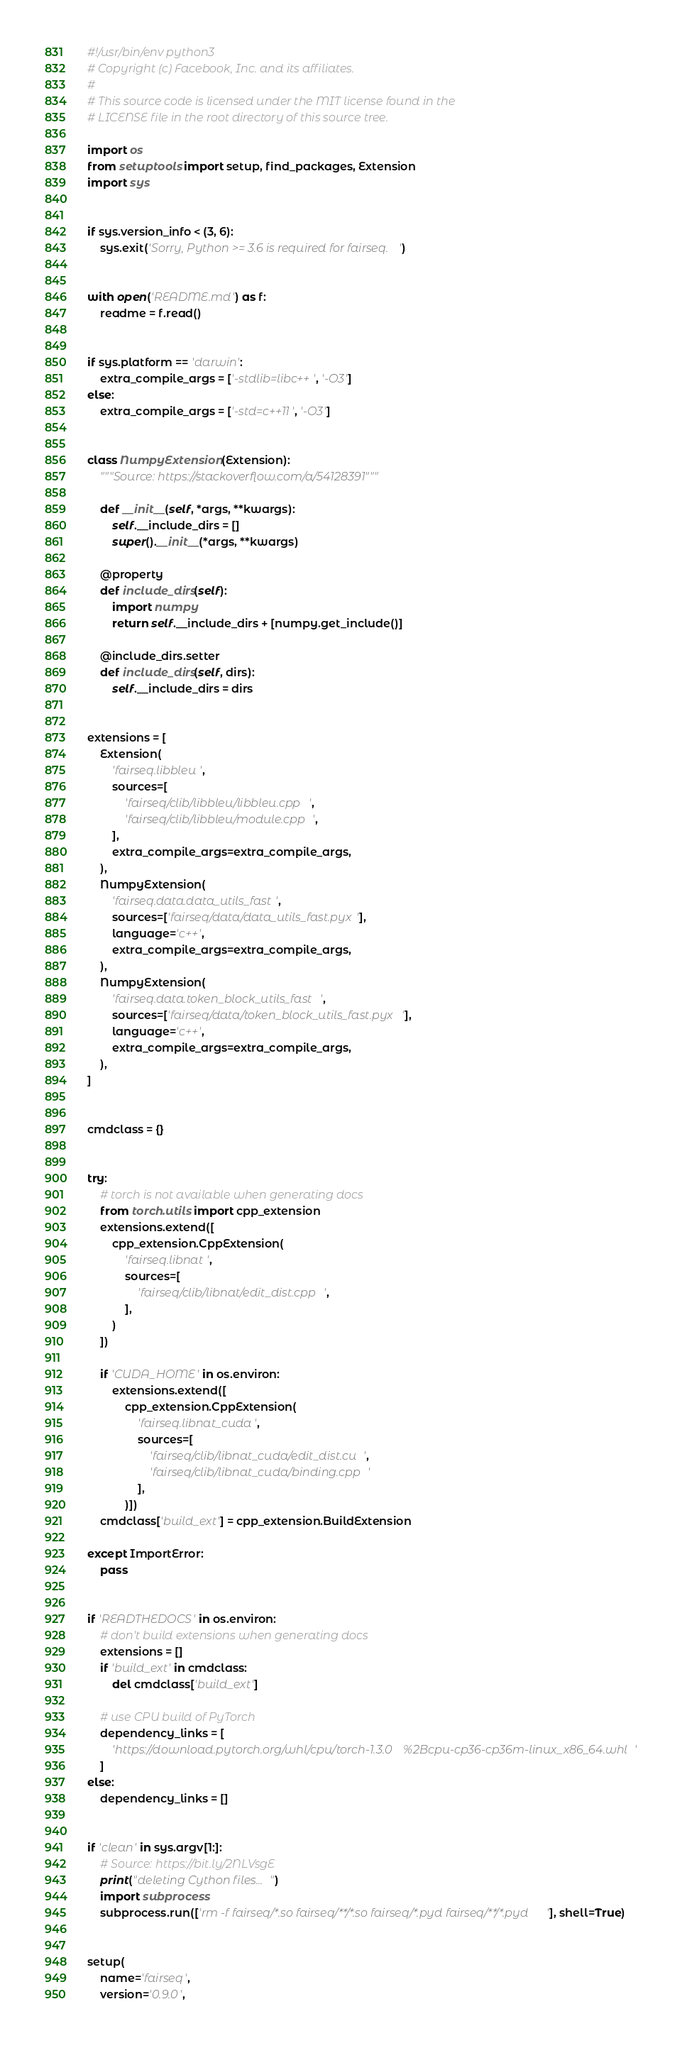<code> <loc_0><loc_0><loc_500><loc_500><_Python_>#!/usr/bin/env python3
# Copyright (c) Facebook, Inc. and its affiliates.
#
# This source code is licensed under the MIT license found in the
# LICENSE file in the root directory of this source tree.

import os
from setuptools import setup, find_packages, Extension
import sys


if sys.version_info < (3, 6):
    sys.exit('Sorry, Python >= 3.6 is required for fairseq.')


with open('README.md') as f:
    readme = f.read()


if sys.platform == 'darwin':
    extra_compile_args = ['-stdlib=libc++', '-O3']
else:
    extra_compile_args = ['-std=c++11', '-O3']


class NumpyExtension(Extension):
    """Source: https://stackoverflow.com/a/54128391"""

    def __init__(self, *args, **kwargs):
        self.__include_dirs = []
        super().__init__(*args, **kwargs)

    @property
    def include_dirs(self):
        import numpy
        return self.__include_dirs + [numpy.get_include()]

    @include_dirs.setter
    def include_dirs(self, dirs):
        self.__include_dirs = dirs


extensions = [
    Extension(
        'fairseq.libbleu',
        sources=[
            'fairseq/clib/libbleu/libbleu.cpp',
            'fairseq/clib/libbleu/module.cpp',
        ],
        extra_compile_args=extra_compile_args,
    ),
    NumpyExtension(
        'fairseq.data.data_utils_fast',
        sources=['fairseq/data/data_utils_fast.pyx'],
        language='c++',
        extra_compile_args=extra_compile_args,
    ),
    NumpyExtension(
        'fairseq.data.token_block_utils_fast',
        sources=['fairseq/data/token_block_utils_fast.pyx'],
        language='c++',
        extra_compile_args=extra_compile_args,
    ),
]


cmdclass = {}


try:
    # torch is not available when generating docs
    from torch.utils import cpp_extension
    extensions.extend([
        cpp_extension.CppExtension(
            'fairseq.libnat',
            sources=[
                'fairseq/clib/libnat/edit_dist.cpp',
            ],
        )
    ])

    if 'CUDA_HOME' in os.environ:
        extensions.extend([
            cpp_extension.CppExtension(
                'fairseq.libnat_cuda',
                sources=[
                    'fairseq/clib/libnat_cuda/edit_dist.cu',
                    'fairseq/clib/libnat_cuda/binding.cpp'
                ],
            )])
    cmdclass['build_ext'] = cpp_extension.BuildExtension

except ImportError:
    pass


if 'READTHEDOCS' in os.environ:
    # don't build extensions when generating docs
    extensions = []
    if 'build_ext' in cmdclass:
        del cmdclass['build_ext']

    # use CPU build of PyTorch
    dependency_links = [
        'https://download.pytorch.org/whl/cpu/torch-1.3.0%2Bcpu-cp36-cp36m-linux_x86_64.whl'
    ]
else:
    dependency_links = []


if 'clean' in sys.argv[1:]:
    # Source: https://bit.ly/2NLVsgE
    print("deleting Cython files...")
    import subprocess
    subprocess.run(['rm -f fairseq/*.so fairseq/**/*.so fairseq/*.pyd fairseq/**/*.pyd'], shell=True)


setup(
    name='fairseq',
    version='0.9.0',</code> 